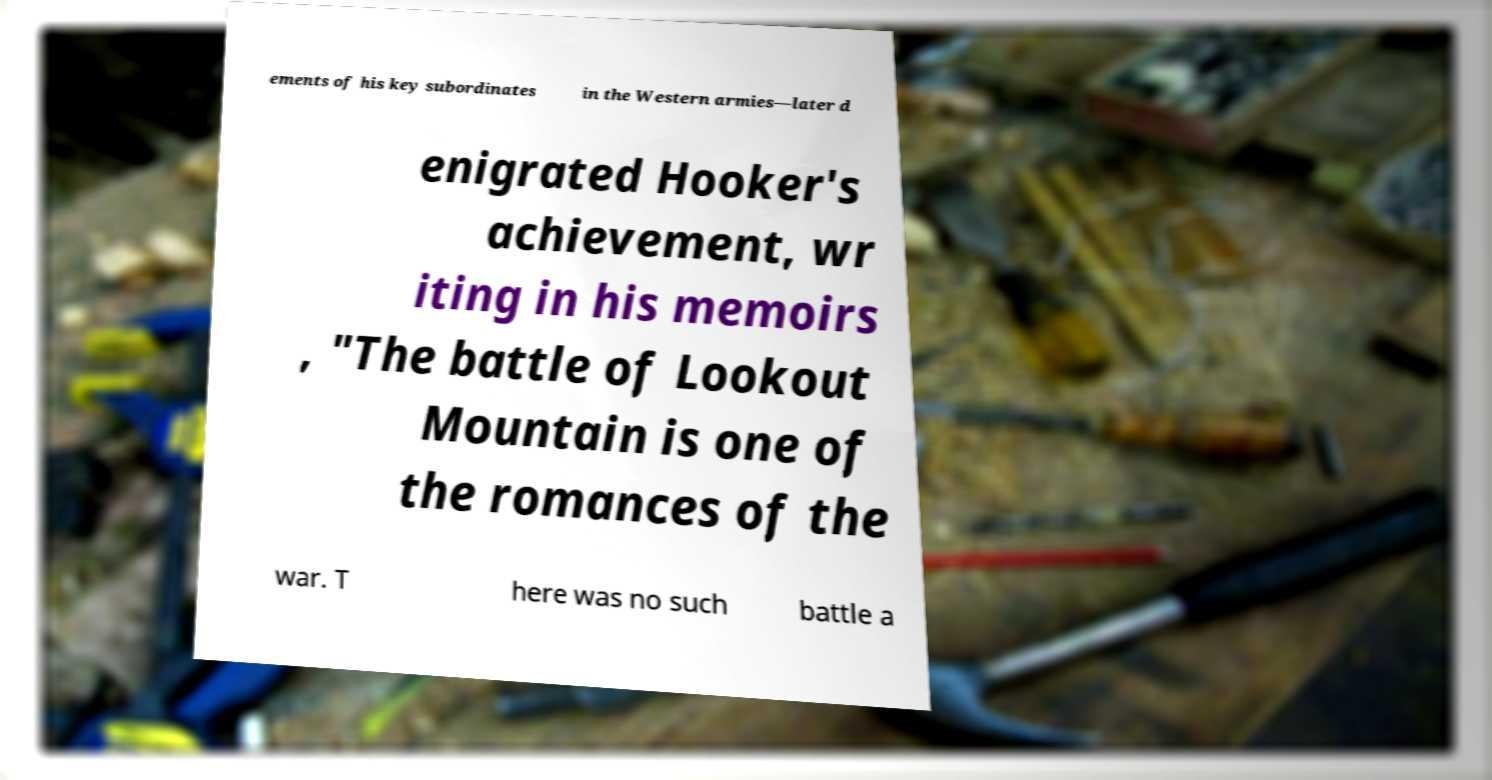Could you extract and type out the text from this image? ements of his key subordinates in the Western armies—later d enigrated Hooker's achievement, wr iting in his memoirs , "The battle of Lookout Mountain is one of the romances of the war. T here was no such battle a 